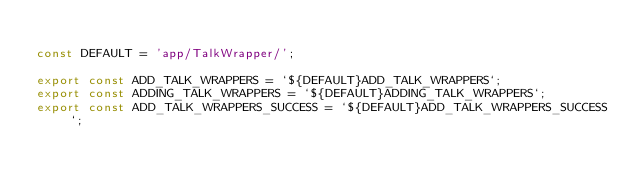<code> <loc_0><loc_0><loc_500><loc_500><_JavaScript_>
const DEFAULT = 'app/TalkWrapper/';

export const ADD_TALK_WRAPPERS = `${DEFAULT}ADD_TALK_WRAPPERS`;
export const ADDING_TALK_WRAPPERS = `${DEFAULT}ADDING_TALK_WRAPPERS`;
export const ADD_TALK_WRAPPERS_SUCCESS = `${DEFAULT}ADD_TALK_WRAPPERS_SUCCESS`;</code> 